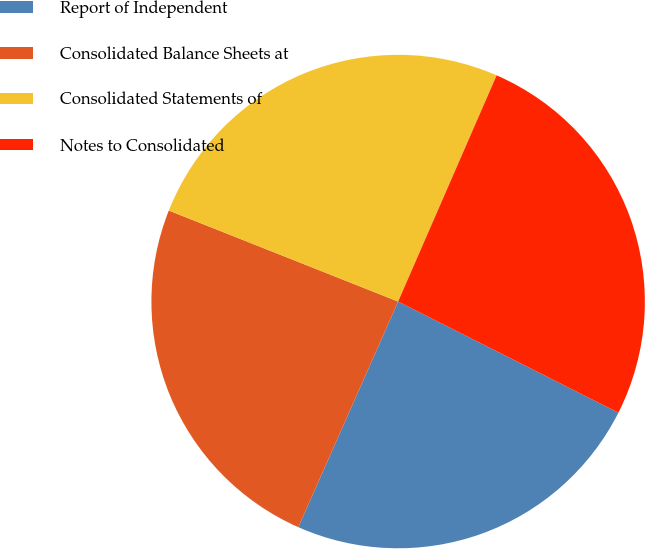Convert chart. <chart><loc_0><loc_0><loc_500><loc_500><pie_chart><fcel>Report of Independent<fcel>Consolidated Balance Sheets at<fcel>Consolidated Statements of<fcel>Notes to Consolidated<nl><fcel>24.19%<fcel>24.38%<fcel>25.52%<fcel>25.9%<nl></chart> 